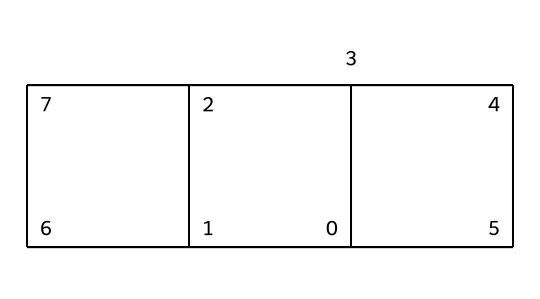What is the molecular formula of cubane? The number of carbon atoms can be counted as 8, and since cubane is a fully saturated hydrocarbon, the number of hydrogen atoms can be calculated using the formula CnH(2n+2), where n is the number of carbon atoms. Therefore, for 8 carbon atoms, the hydrogen count is 18. Thus, the molecular formula is C8H8.
Answer: C8H8 How many carbon atoms are there in cubane? The SMILES notation indicates that the structure is composed of several interconnected carbon atoms. By interpreting the structure, we can count a total of 8 carbon atoms.
Answer: 8 What type of symmetry does cubane exhibit? Cubane has a high degree of symmetry; specifically, it exhibits octahedral symmetry because all its carbon atoms are equivalent and uniformly arranged in three-dimensional space.
Answer: octahedral What is the bond angle between the carbon atoms in cubane? In cubane, due to its cubic structure, the bond angles between adjacent carbon atoms are approximately 90 degrees. This is characteristic of the geometric arrangement of copper-like cubical compounds.
Answer: 90 degrees Is cubane a saturated or unsaturated hydrocarbon? Cubane contains only single bonds between carbon atoms and hydrogen atoms, making it fully saturated with no double or triple bonds present in its structure.
Answer: saturated What is the significance of cubane’s structure related to its potential fuel applications? The cubic structure of cubane allows for high energy density due to the strain in its C-C bonds, which can release substantial energy upon combustion, making it a candidate for high-energy fuels.
Answer: high energy density 